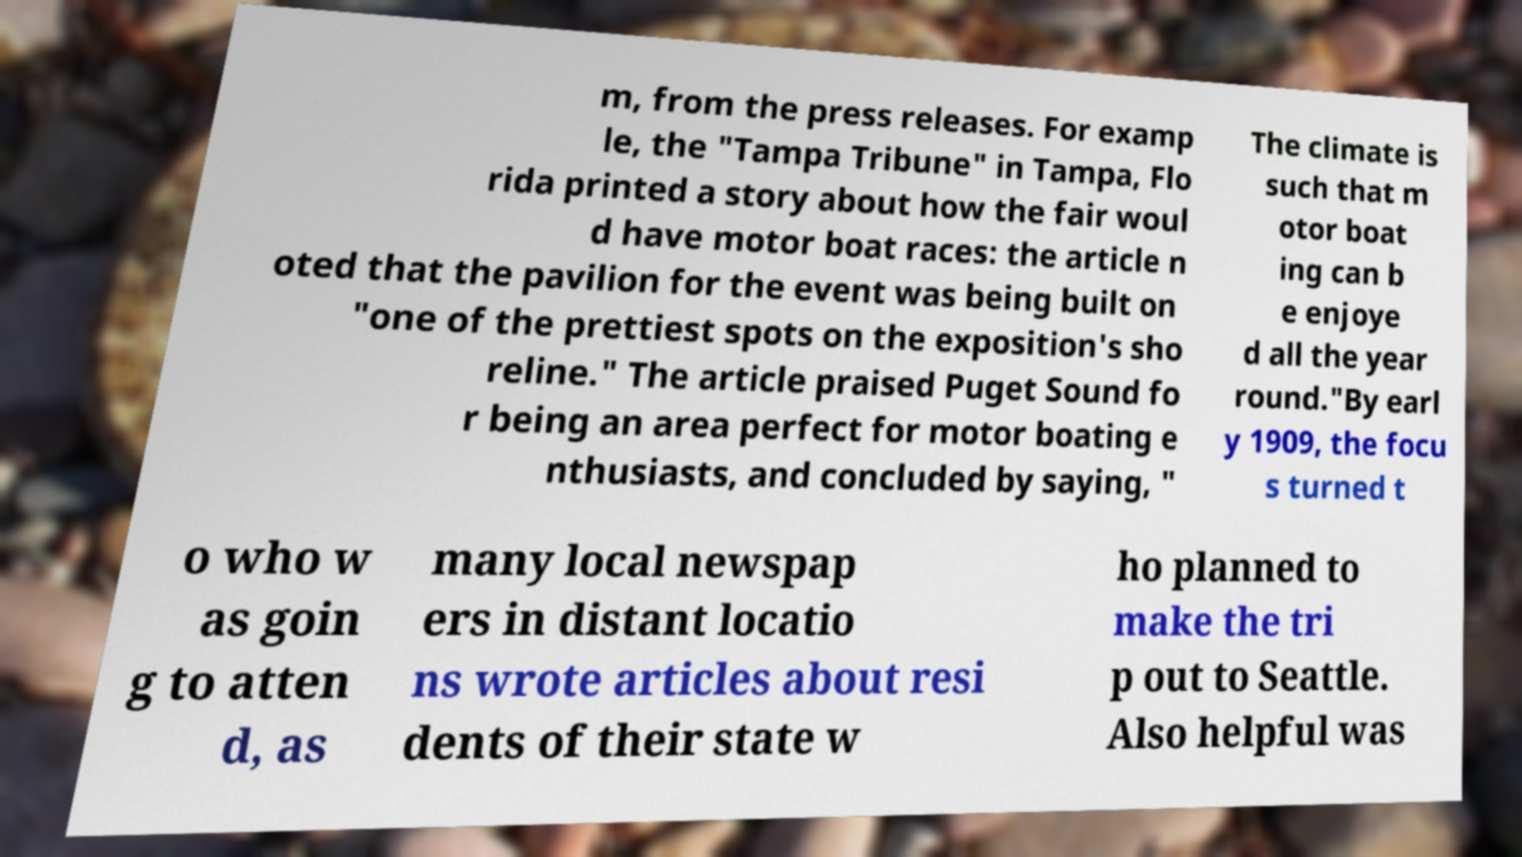Please identify and transcribe the text found in this image. m, from the press releases. For examp le, the "Tampa Tribune" in Tampa, Flo rida printed a story about how the fair woul d have motor boat races: the article n oted that the pavilion for the event was being built on "one of the prettiest spots on the exposition's sho reline." The article praised Puget Sound fo r being an area perfect for motor boating e nthusiasts, and concluded by saying, " The climate is such that m otor boat ing can b e enjoye d all the year round."By earl y 1909, the focu s turned t o who w as goin g to atten d, as many local newspap ers in distant locatio ns wrote articles about resi dents of their state w ho planned to make the tri p out to Seattle. Also helpful was 